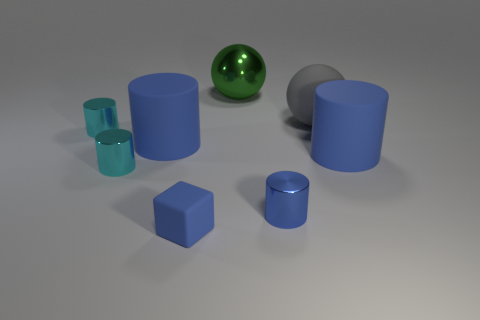There is a large blue rubber thing that is to the right of the big cylinder that is left of the blue matte thing on the right side of the tiny blue block; what is its shape?
Provide a succinct answer. Cylinder. There is a matte ball that is the same size as the green metal ball; what is its color?
Provide a succinct answer. Gray. What number of tiny rubber things have the same shape as the large gray object?
Ensure brevity in your answer.  0. There is a gray matte sphere; is its size the same as the sphere that is left of the blue metallic object?
Give a very brief answer. Yes. What is the shape of the large blue thing to the right of the green shiny ball that is behind the tiny blue rubber thing?
Make the answer very short. Cylinder. Is the number of large gray spheres on the right side of the large rubber ball less than the number of large gray spheres?
Your answer should be very brief. Yes. What shape is the tiny object that is the same color as the matte cube?
Your response must be concise. Cylinder. How many gray objects are the same size as the gray sphere?
Your answer should be compact. 0. What shape is the small metal thing on the right side of the green shiny sphere?
Offer a very short reply. Cylinder. Is the number of gray blocks less than the number of matte cylinders?
Keep it short and to the point. Yes. 